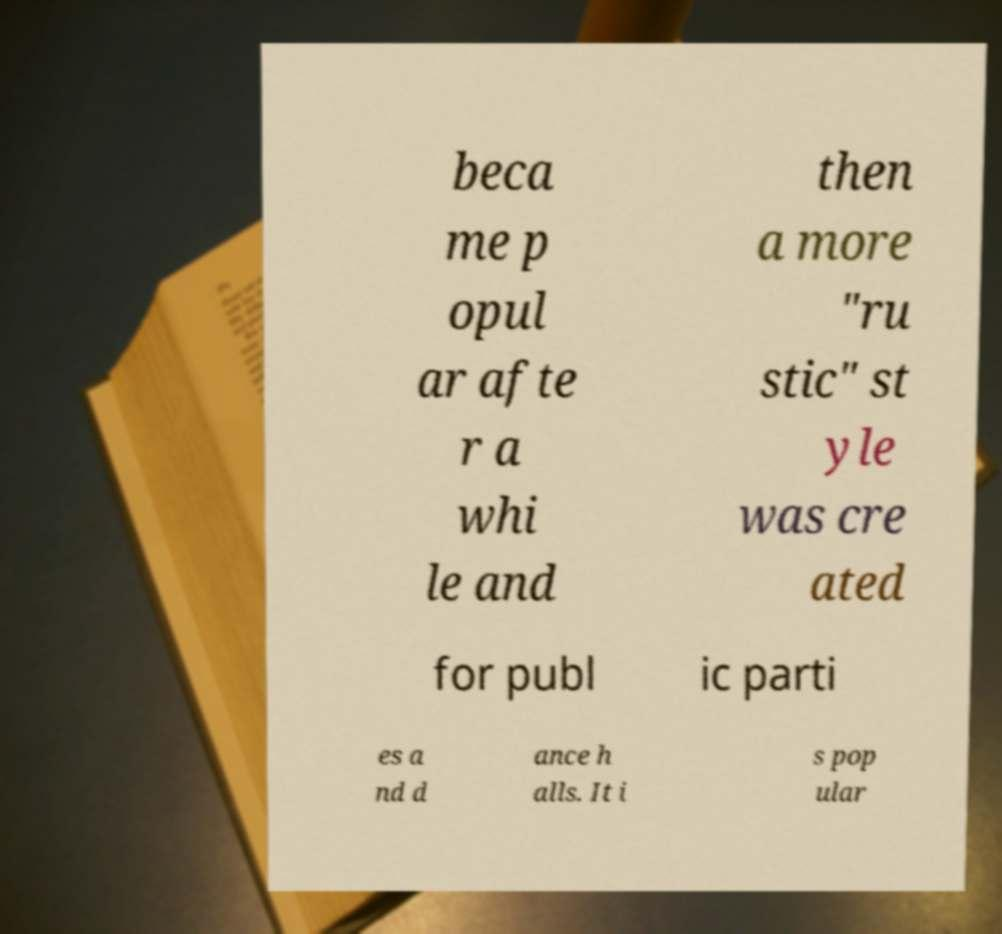There's text embedded in this image that I need extracted. Can you transcribe it verbatim? beca me p opul ar afte r a whi le and then a more "ru stic" st yle was cre ated for publ ic parti es a nd d ance h alls. It i s pop ular 